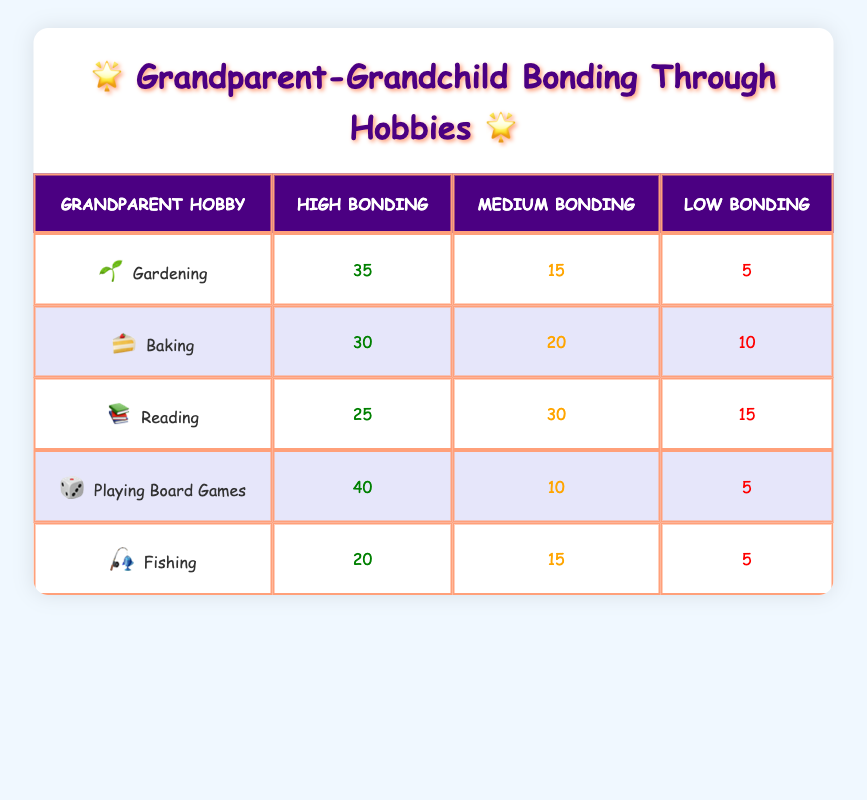What is the highest bonding level recorded for gardening? The table shows that under the Grandparent Hobby of Gardening, the Count for High Bonding Level is 35. Therefore, the highest bonding level recorded is 35 for gardening.
Answer: 35 How many grandparents have a medium bonding level when baking? Referring to the Baking row in the table, the Count for Medium Bonding Level is 20. Therefore, 20 grandparents have a medium bonding level with this hobby.
Answer: 20 Which hobby has the highest count of high bonding? Looking at the High Bonding counts across all hobbies, Playing Board Games has the highest at 40. Thus, it is the hobby with the highest count of high bonding.
Answer: Playing Board Games What is the total number of grandparents who reported low bonding across all hobbies? To find this, we sum the counts for Low Bonding levels across all hobbies: 5 (Gardening) + 10 (Baking) + 15 (Reading) + 5 (Playing Board Games) + 5 (Fishing) = 40. Therefore, there are 40 grandparents in total who reported low bonding.
Answer: 40 Is it true that reading has more high bonding counts than fishing? In the table, Reading has a High Bonding Count of 25, while Fishing has a High Bonding Count of 20. Since 25 is greater than 20, it is true that reading has more high bonding counts than fishing.
Answer: Yes Which hobby shows the most balanced distribution of bonding levels? By examining the counts for each bonding level across hobbies, Baking has counts of 30 (High), 20 (Medium), and 10 (Low). This spread suggests a more balanced distribution compared to others. Most approaches 50-50-0.
Answer: Baking What is the average high bonding count across all listed hobbies? To calculate the average high bonding count, first sum the high bonding counts: 35 (Gardening) + 30 (Baking) + 25 (Reading) + 40 (Playing Board Games) + 20 (Fishing) = 180. There are 5 hobbies, so the average is 180 / 5 = 36.
Answer: 36 Which bonding level has the least amount of counts in playing board games? In the Playing Board Games row, the least count is for the Low Bonding level, which is 5. This indicates that there are fewer grandparents reporting low bonding for this activity.
Answer: 5 Which hobby has the largest difference between high and low bonding counts? To determine the largest difference, we calculate the difference for each hobby: Gardening (35 - 5 = 30), Baking (30 - 10 = 20), Reading (25 - 15 = 10), Playing Board Games (40 - 5 = 35), and Fishing (20 - 5 = 15). The largest difference is for Playing Board Games with 35.
Answer: Playing Board Games 